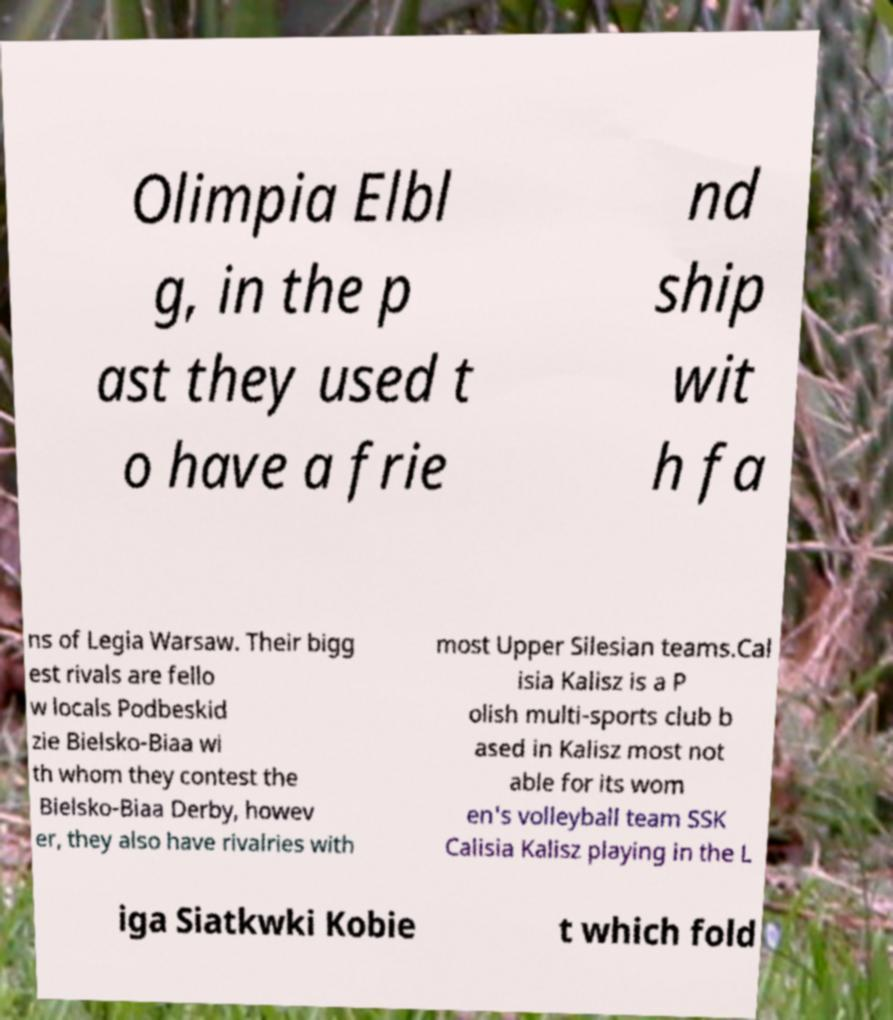There's text embedded in this image that I need extracted. Can you transcribe it verbatim? Olimpia Elbl g, in the p ast they used t o have a frie nd ship wit h fa ns of Legia Warsaw. Their bigg est rivals are fello w locals Podbeskid zie Bielsko-Biaa wi th whom they contest the Bielsko-Biaa Derby, howev er, they also have rivalries with most Upper Silesian teams.Cal isia Kalisz is a P olish multi-sports club b ased in Kalisz most not able for its wom en's volleyball team SSK Calisia Kalisz playing in the L iga Siatkwki Kobie t which fold 